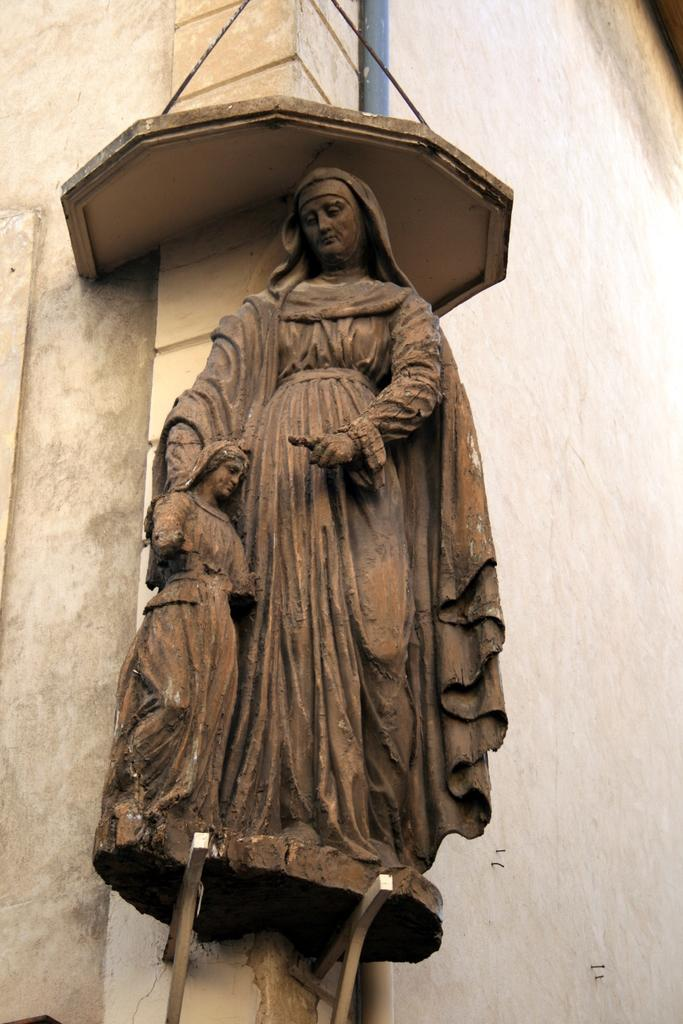What is the main subject in the center of the image? There is a statue in the center of the image. What can be seen in the background of the image? There is a wall and a pipe in the background of the image. How many cats are sitting on the statue's foot in the image? There are no cats present in the image, and the statue does not have a foot. 